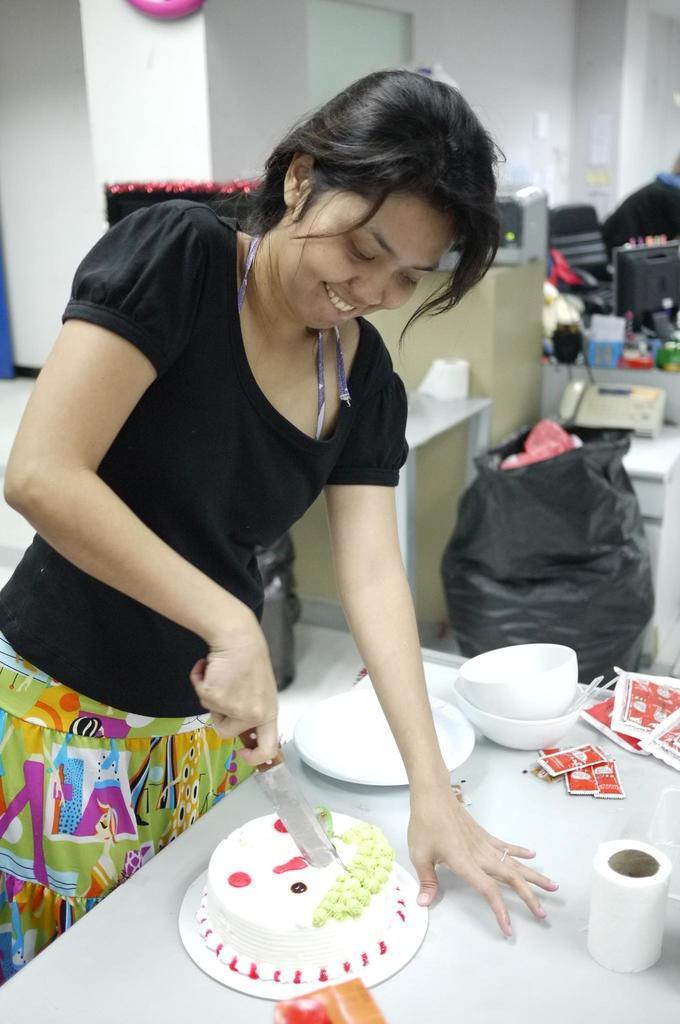Please provide a concise description of this image. In the center of the image we can see a woman is standing and she is smiling and she is holding a knife. In front of her, there is a table. On the table, we can see a plate, cake, bowls and a few other objects. In the background there is a wall, black polythene bag and a few other objects. 